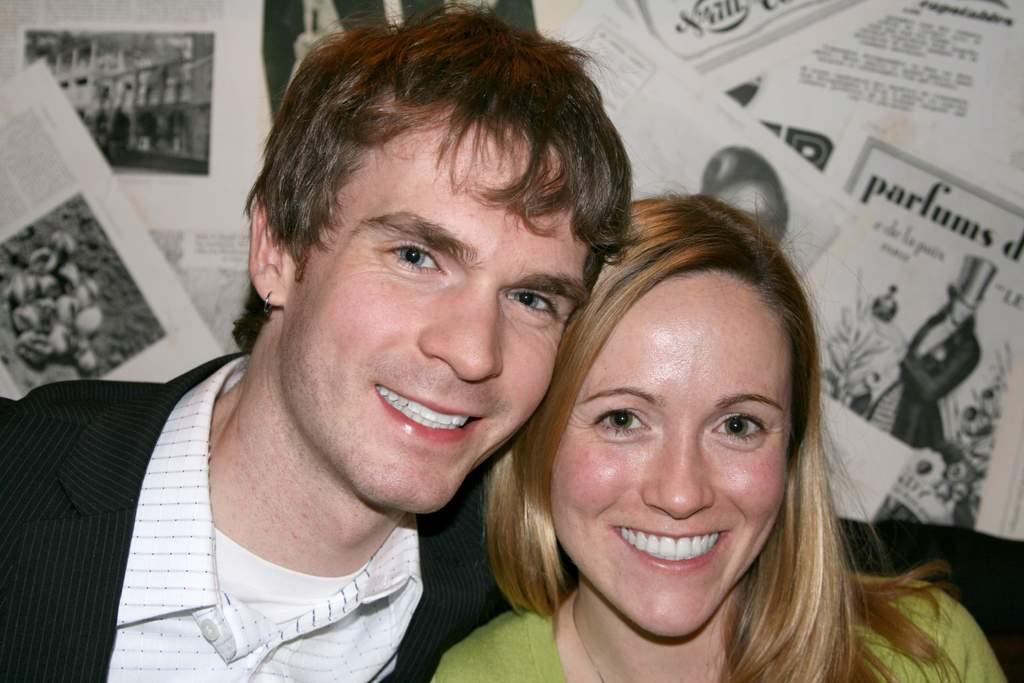Who is present in the image? There is a man and a woman in the image. What are the man and woman doing in the image? The man and woman are smiling in the image. What can be seen on the back of the man and woman? Paper posters are visible on the back of the man and woman. What is the man wearing in the image? The man is wearing a coat in the image. How many tails can be seen on the man and woman in the image? There are no tails visible on the man and woman in the image. What type of joke is the man telling the woman in the image? There is no indication of a joke being told in the image; the man and woman are simply smiling. 